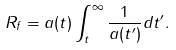Convert formula to latex. <formula><loc_0><loc_0><loc_500><loc_500>R _ { f } = a ( t ) \int _ { t } ^ { \infty } \frac { 1 } { a ( t ^ { \prime } ) } d t ^ { \prime } .</formula> 